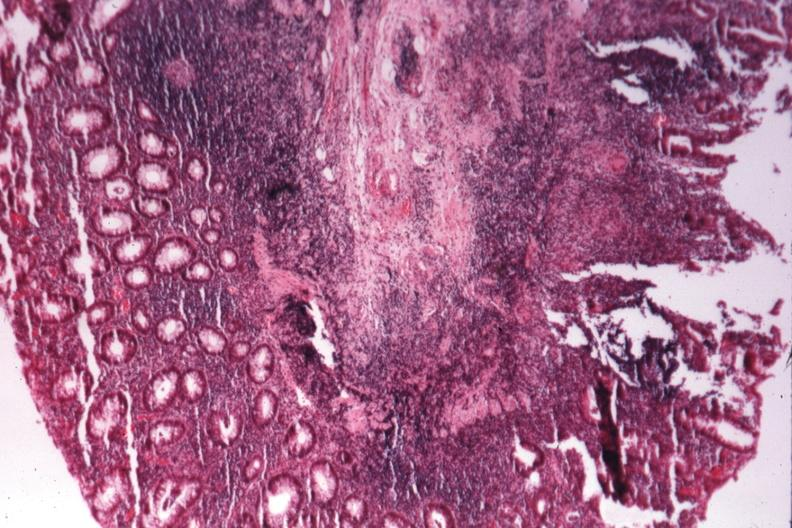does this image show source of granulomatous colitis?
Answer the question using a single word or phrase. Yes 